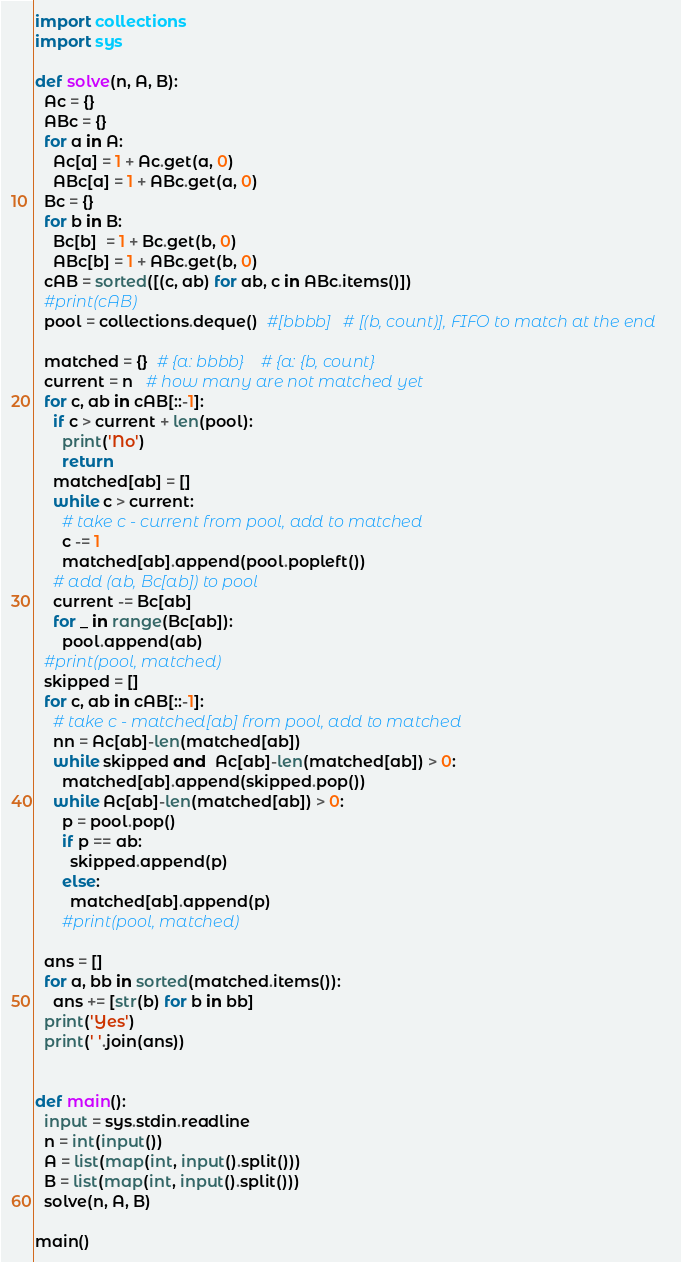Convert code to text. <code><loc_0><loc_0><loc_500><loc_500><_Python_>import collections
import sys

def solve(n, A, B):
  Ac = {}
  ABc = {}
  for a in A:
    Ac[a] = 1 + Ac.get(a, 0)
    ABc[a] = 1 + ABc.get(a, 0)
  Bc = {}
  for b in B:
    Bc[b]  = 1 + Bc.get(b, 0)
    ABc[b] = 1 + ABc.get(b, 0)
  cAB = sorted([(c, ab) for ab, c in ABc.items()])
  #print(cAB)
  pool = collections.deque()  #[bbbb]   # [(b, count)], FIFO to match at the end

  matched = {}  # {a: bbbb}    # {a: {b, count}
  current = n   # how many are not matched yet
  for c, ab in cAB[::-1]:
    if c > current + len(pool):
      print('No')
      return
    matched[ab] = []
    while c > current:
      # take c - current from pool, add to matched
      c -= 1
      matched[ab].append(pool.popleft())
    # add (ab, Bc[ab]) to pool
    current -= Bc[ab]
    for _ in range(Bc[ab]):
      pool.append(ab)
  #print(pool, matched)
  skipped = []
  for c, ab in cAB[::-1]:
    # take c - matched[ab] from pool, add to matched
    nn = Ac[ab]-len(matched[ab])
    while skipped and  Ac[ab]-len(matched[ab]) > 0:
      matched[ab].append(skipped.pop())
    while Ac[ab]-len(matched[ab]) > 0:
      p = pool.pop()
      if p == ab:
        skipped.append(p)
      else:
        matched[ab].append(p)
      #print(pool, matched)

  ans = []
  for a, bb in sorted(matched.items()):
    ans += [str(b) for b in bb]
  print('Yes')
  print(' '.join(ans))


def main():
  input = sys.stdin.readline
  n = int(input())
  A = list(map(int, input().split()))
  B = list(map(int, input().split()))
  solve(n, A, B)

main()
</code> 